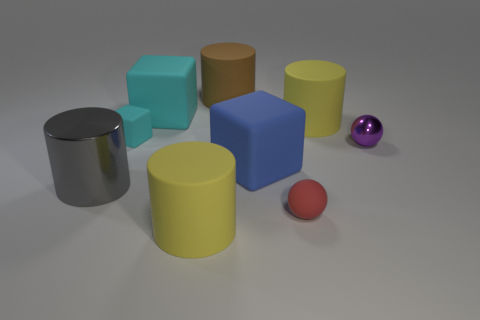Is the number of yellow cylinders behind the big shiny thing greater than the number of large cylinders behind the tiny cyan thing?
Your answer should be very brief. No. What number of red spheres have the same material as the purple thing?
Your answer should be compact. 0. Is the red matte object the same size as the metal sphere?
Offer a very short reply. Yes. The shiny cylinder is what color?
Keep it short and to the point. Gray. How many things are either tiny gray matte blocks or brown cylinders?
Ensure brevity in your answer.  1. Are there any red things that have the same shape as the small purple thing?
Your response must be concise. Yes. There is a big cylinder behind the big cyan matte object; does it have the same color as the metal cylinder?
Your answer should be compact. No. What is the shape of the yellow rubber object that is behind the metal object that is behind the gray cylinder?
Your response must be concise. Cylinder. Are there any other purple metallic spheres that have the same size as the shiny ball?
Your response must be concise. No. Are there fewer tiny things than tiny metal spheres?
Provide a short and direct response. No. 